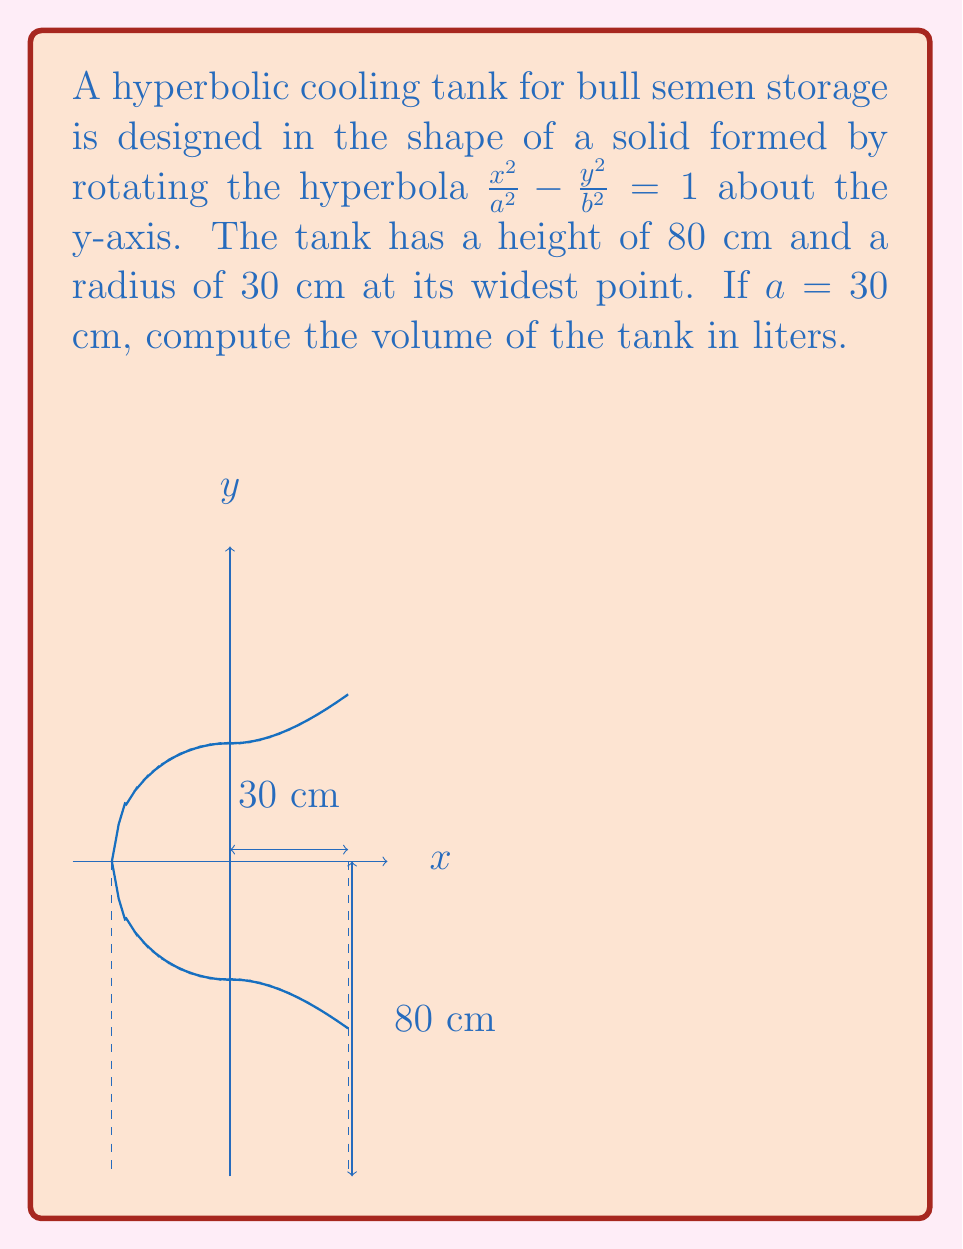Give your solution to this math problem. To compute the volume of the hyperbolic cooling tank, we'll use the formula for the volume of a solid of revolution:

$$V = \pi \int_0^h [f(y)]^2 dy$$

Where $f(y)$ is the function describing the curve in terms of y, and $h$ is the height of the tank.

Steps:
1) First, we need to express $x$ in terms of $y$ from the hyperbola equation:

   $$\frac{x^2}{a^2} - \frac{y^2}{b^2} = 1$$
   $$x^2 = a^2(1 + \frac{y^2}{b^2})$$
   $$x = \pm a\sqrt{1 + \frac{y^2}{b^2}}$$

2) We're given $a = 30$ cm, and we can find $b$ using the information that the radius at the widest point (y = 0) is 30 cm:

   $$30 = a\sqrt{1 + \frac{0^2}{b^2}} = a = 30$$

3) Now we can write our integral:

   $$V = \pi \int_0^{80} [30\sqrt{1 + \frac{y^2}{30^2}}]^2 dy$$

4) Simplify:

   $$V = 900\pi \int_0^{80} (1 + \frac{y^2}{900}) dy$$

5) Integrate:

   $$V = 900\pi [y + \frac{y^3}{2700}]_0^{80}$$

6) Evaluate the limits:

   $$V = 900\pi [(80 + \frac{80^3}{2700}) - (0 + \frac{0^3}{2700})]$$
   $$V = 900\pi [80 + \frac{512000}{2700}]$$
   $$V = 900\pi [80 + 189.63]$$
   $$V = 900\pi (269.63)$$
   $$V = 242,667 \text{ cm}^3$$

7) Convert to liters:

   $$V = 242.667 \text{ liters}$$
Answer: 242.667 liters 